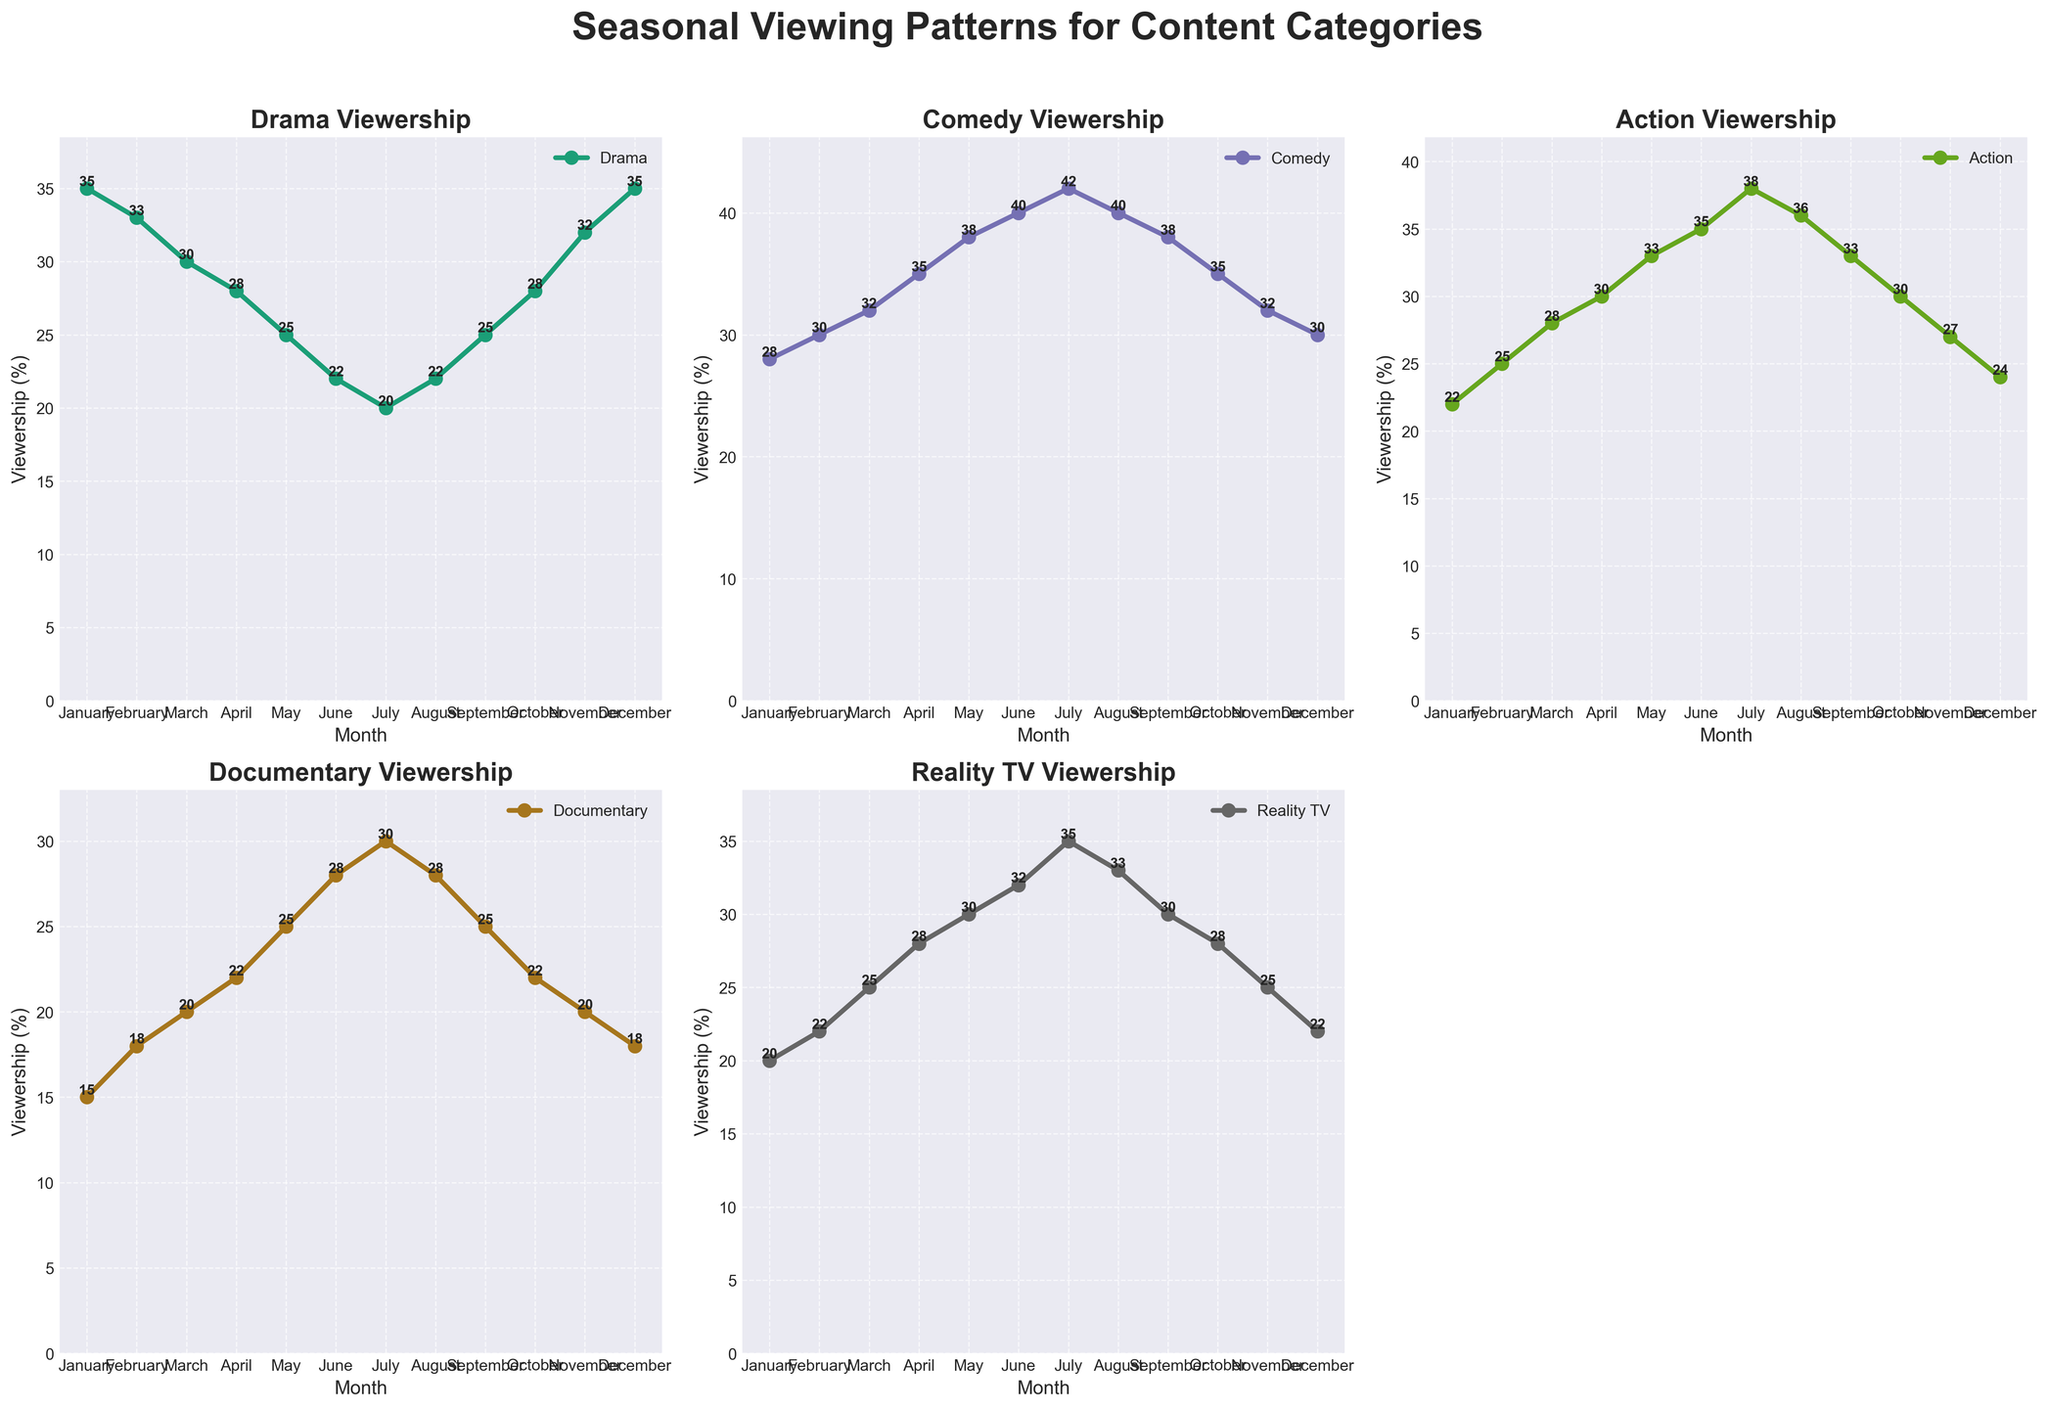What month has the highest viewership for Drama? The Drama viewership plot shows that December and January have the highest values at 35%. December and January both have the highest viewership for Drama
Answer: December and January Which content category sees the most significant increase in viewership from January to February? By comparing the changes from January to February across all categories, we see Drama decreases by 2%, Comedy increases by 2%, Action increases by 3%, Documentary increases by 3%, and Reality TV increases by 2%. Action and Documentary both show a significant increase of 3% each
Answer: Action and Documentary What is the average viewership for Comedy from January to June? Summing up the Comedy viewership from January to June: (28 + 30 + 32 + 35 + 38 + 40) = 203. Then divide by the number of months (6). The average is 203 / 6
Answer: 33.83 In which month(s) does Reality TV have the same viewership as Action? Viewing the Reality TV and Action plots, both have the same value in May (30%) and August (33%). May and August have matching viewership for Reality TV and Action
Answer: May and August Does Documentary viewership ever exceed Drama viewership, and if so, in which month(s)? By comparing the Documentary and Drama plots, we observe that Drama values are always higher than Documentary values across all months. Documentary viewership never exceeds Drama viewership
Answer: Never What month has the lowest viewership for Action? Referring to the Action plot, the lowest value appears in January at 22%. January has the lowest viewership for Action
Answer: January How does the viewership trend for Comedy change from April to July? Looking at the Comedy plot, the values increase over time from April to July: April (35%), May (38%), June (40%), and July (42%). The Comedy viewership consistently increases from April to July
Answer: It increases Compare the May viewership for Drama and Reality TV. Which category has higher viewership, and by how much? In May, Drama viewership is 25%, and Reality TV viewership is 30%. Reality TV has higher viewership, and the difference is 30% - 25% = 5%. Reality TV has higher viewership by 5% in May
Answer: Reality TV by 5% Which two content categories have the closest average viewership over the entire year? To find the closest averages, we calculate the average viewership for each category: Drama: (35+33+30+28+25+22+20+22+25+28+32+35)/12 = 28.67, Comedy: (28+30+32+35+38+40+42+40+38+35+32+30)/12 = 34.33, Action: (22+25+28+30+33+35+38+36+33+30+27+24)/12 = 30.25, Documentary: (15+18+20+22+25+28+30+28+25+22+20+18)/12 = 22.67, Reality TV: (20+22+25+28+30+32+35+33+30+28+25+22)/12 = 27.5. The closest averages are between Drama (28.67) and Action (30.25), with a difference of 1.58 closer to Drama and Reality TV (27.5) with a difference of 1.17 closer to each other. Reality TV and Drama have the closest average viewership over the entire year
Answer: Drama and Reality TV 